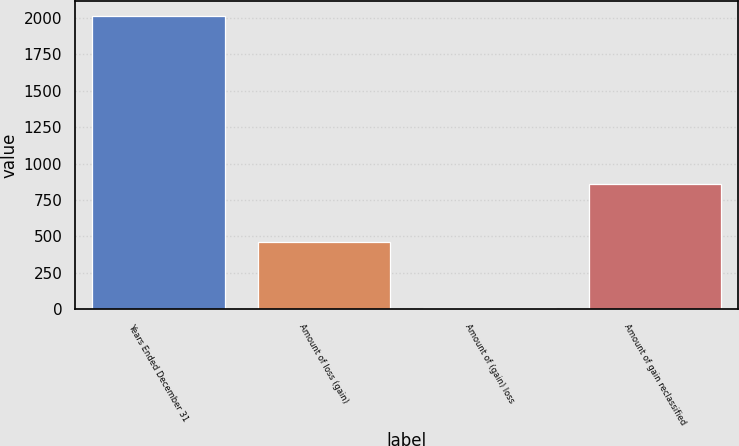Convert chart to OTSL. <chart><loc_0><loc_0><loc_500><loc_500><bar_chart><fcel>Years Ended December 31<fcel>Amount of loss (gain)<fcel>Amount of (gain) loss<fcel>Amount of gain reclassified<nl><fcel>2015<fcel>461<fcel>7<fcel>862.6<nl></chart> 